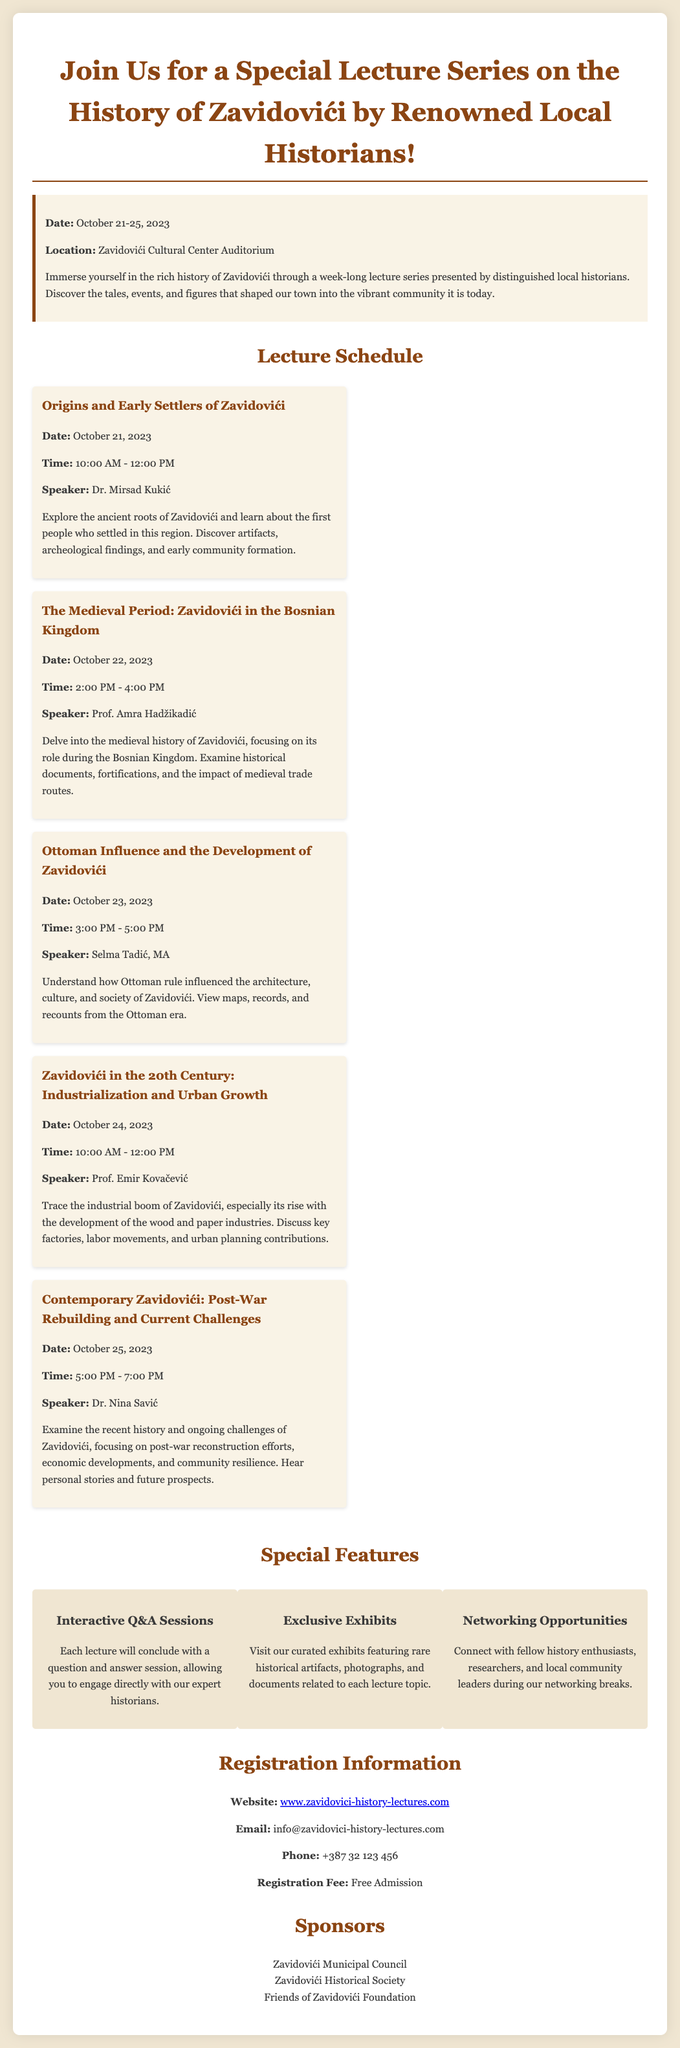What are the dates of the lecture series? The dates are provided in the document as October 21-25, 2023.
Answer: October 21-25, 2023 Who is the speaker for the lecture on the medieval period? The document lists the speaker for this event as Prof. Amra Hadžikadić.
Answer: Prof. Amra Hadžikadić What topic will be discussed on October 24, 2023? The schedule details that the topic for this date is "Zavidovići in the 20th Century: Industrialization and Urban Growth."
Answer: Zavidovići in the 20th Century: Industrialization and Urban Growth What is the registration fee for the lecture series? The document explicitly states that the registration fee is free admission.
Answer: Free Admission What feature allows interaction with historians? The document highlights that there will be "Interactive Q&A Sessions" following each lecture.
Answer: Interactive Q&A Sessions Which organization is one of the sponsors mentioned? One of the listed sponsors in the document is the Zavidovići Historical Society.
Answer: Zavidovići Historical Society What is the location of the lectures? The document specifies that the lectures will take place at the Zavidovići Cultural Center Auditorium.
Answer: Zavidovići Cultural Center Auditorium What is the time for the lecture on Ottoman influence? The scheduled time for this lecture is from 3:00 PM to 5:00 PM on October 23, 2023.
Answer: 3:00 PM - 5:00 PM 